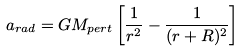Convert formula to latex. <formula><loc_0><loc_0><loc_500><loc_500>a _ { r a d } = G M _ { p e r t } \left [ \frac { 1 } { r ^ { 2 } } - \frac { 1 } { ( r + R ) ^ { 2 } } \right ]</formula> 